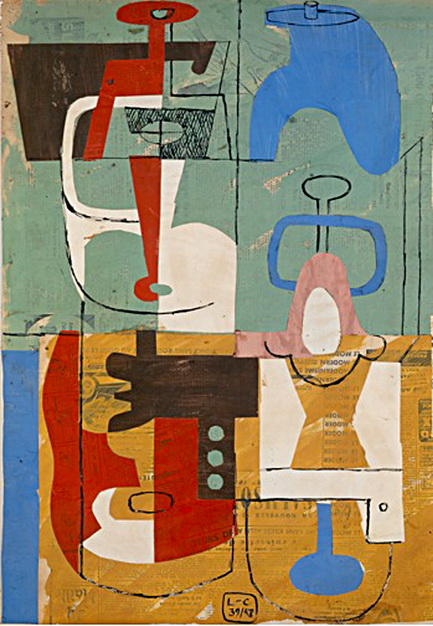What might the use of vibrant colors and geometric shapes suggest about the artist's intent? The use of vibrant colors and bold geometric shapes in the artwork may suggest the artist's intent to evoke emotional responses and convey dynamic energy. These elements often symbolize modernity and the dissection of conventional reality, which are hallmarks of the Cubist movement. The artist might be exploring themes of complexity in human perception or the fragmentation of the modern world.  Are there any cultural or historical influences reflected in this artwork? Indeed, the artwork appears to reflect the cultural ferment of early 20th-century modernism, where artists experimented with new forms of expression. The influences of Cubism are apparent, a movement initiated by artists like Pablo Picasso and Georges Braque, who challenged traditional perspectives and embraced abstract forms. Additionally, the textural elements and earthy colors might indicate influences from African or native arts, which were often incorporated into European avant-garde art of the period. 